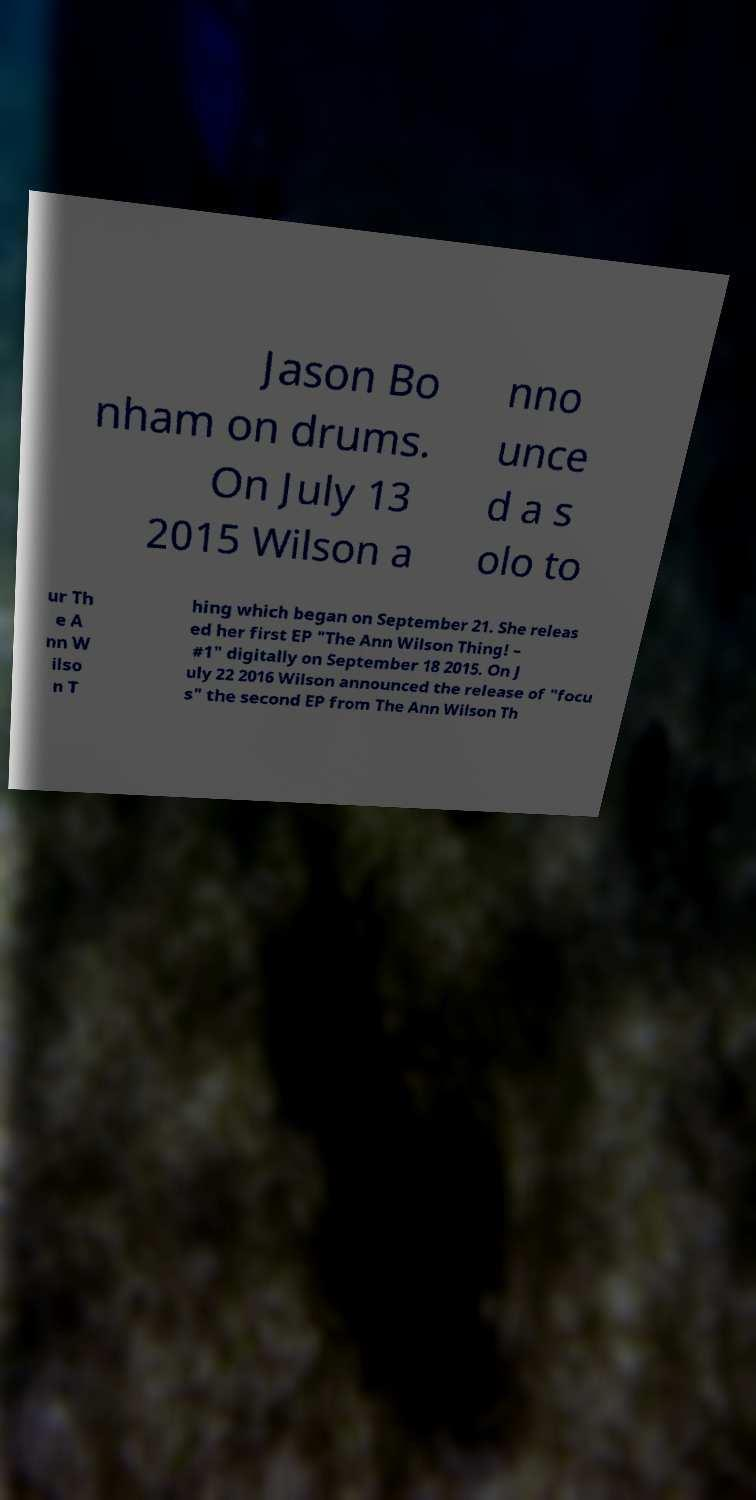Can you accurately transcribe the text from the provided image for me? Jason Bo nham on drums. On July 13 2015 Wilson a nno unce d a s olo to ur Th e A nn W ilso n T hing which began on September 21. She releas ed her first EP "The Ann Wilson Thing! – #1" digitally on September 18 2015. On J uly 22 2016 Wilson announced the release of "focu s" the second EP from The Ann Wilson Th 